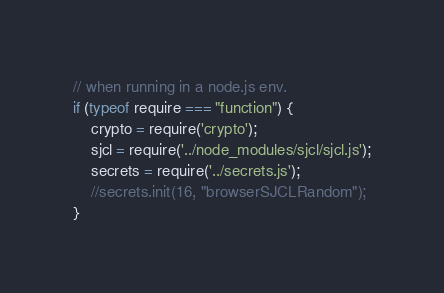<code> <loc_0><loc_0><loc_500><loc_500><_JavaScript_>// when running in a node.js env.
if (typeof require === "function") {
    crypto = require('crypto');
    sjcl = require('../node_modules/sjcl/sjcl.js');
    secrets = require('../secrets.js');
    //secrets.init(16, "browserSJCLRandom");
}
</code> 